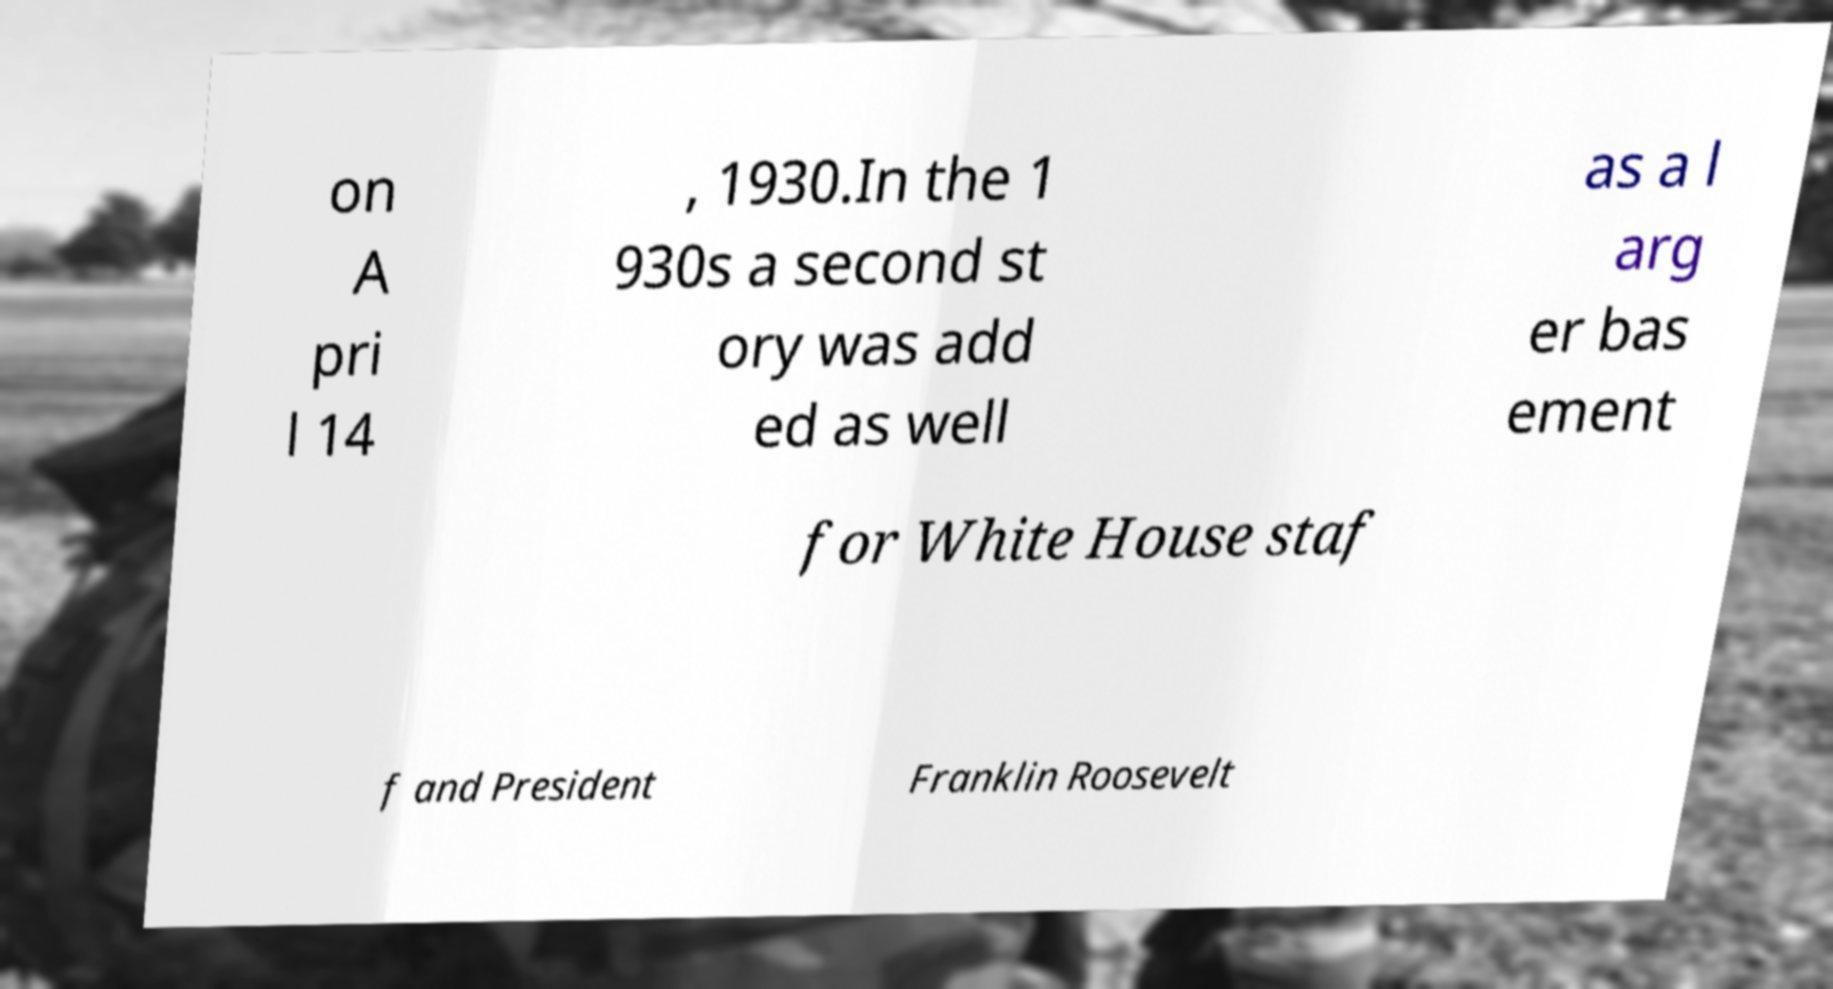Can you accurately transcribe the text from the provided image for me? on A pri l 14 , 1930.In the 1 930s a second st ory was add ed as well as a l arg er bas ement for White House staf f and President Franklin Roosevelt 